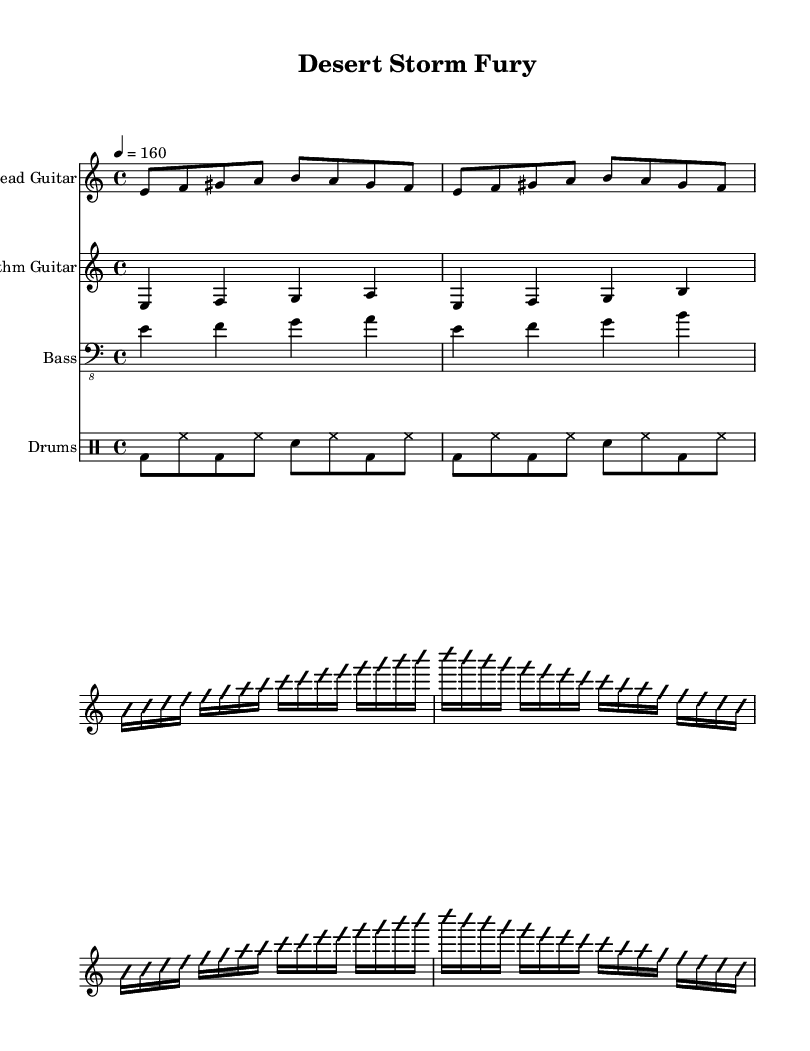What is the key signature of this music? The key signature indicates that the piece is in E Phrygian, which has one sharp (F#). This can be identified from the global variable set to \key e \phrygian.
Answer: E Phrygian What is the time signature of the piece? The time signature is 4/4, as specified in the global variable \time 4/4. This means there are four beats per measure, and a quarter note gets one beat.
Answer: 4/4 What is the tempo marking indicated in the sheet music? The tempo marking shows 4 = 160, indicating that a quarter note should be played at a speed of 160 beats per minute. This is found in the global variable \tempo 4 = 160.
Answer: 160 How many measures are in the lead guitar's main riff section? The main riff repeats twice, with two measures each time, making a total of four measures. This is determined by the \repeat unfold 2 command, which indicates repetition.
Answer: 4 What type of scales are used to influence the guitar solos? The guitar solos are inspired by Arabic maqam scales, indicated by the use of specific notes in a scale that reflects Middle Eastern musical traditions, as seen from the melodic lines in the solo section.
Answer: Arabic maqam What is the time division of the simplified guitar solo section? The simplified guitar solo section is composed of 16th notes, which can be identified by the use of b16, indicating their rhythmic length, resulting in faster note transitions.
Answer: 16th notes What is the rhythmic pattern of the drums section in the piece? The rhythmic pattern of the drums alternates between bass drum, hi-hat, and snare hitting in a consistent sequence, identified through the drummode notation, showcasing a common metal drumming style.
Answer: Alternating bass, hi-hat, snare 